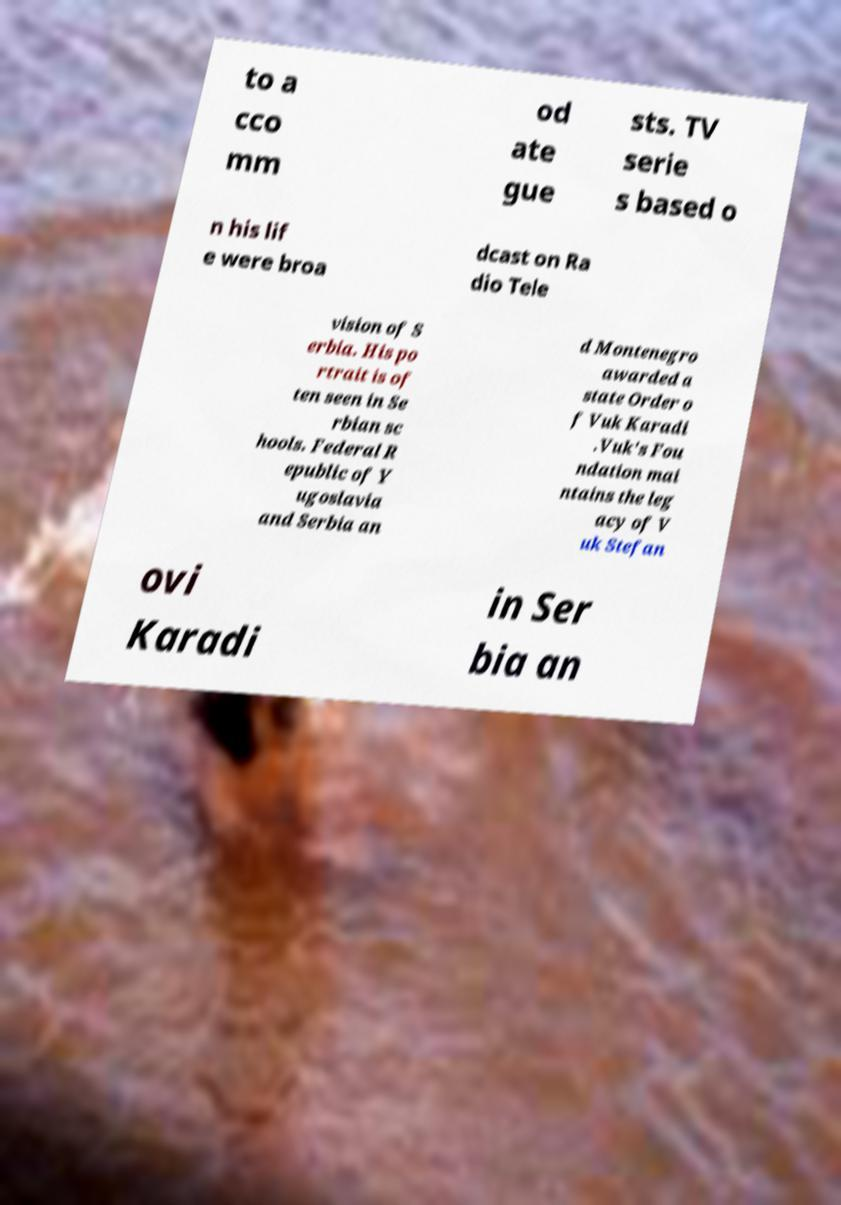Please identify and transcribe the text found in this image. to a cco mm od ate gue sts. TV serie s based o n his lif e were broa dcast on Ra dio Tele vision of S erbia. His po rtrait is of ten seen in Se rbian sc hools. Federal R epublic of Y ugoslavia and Serbia an d Montenegro awarded a state Order o f Vuk Karadi .Vuk's Fou ndation mai ntains the leg acy of V uk Stefan ovi Karadi in Ser bia an 